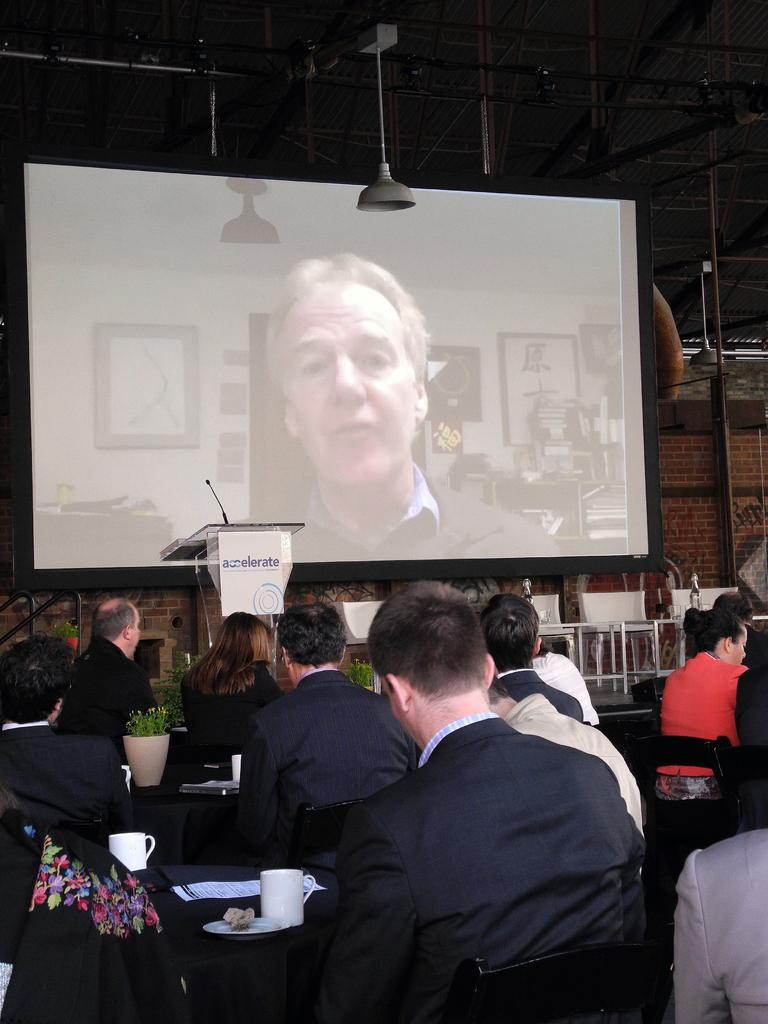What is the main activity taking place in the image? Many people are sitting on chairs in the image, suggesting a gathering or event. What can be found on the stage in the image? There are chairs and a projector screen on the stage in the image. What is the purpose of the mic table in the image? The mic table is likely used for holding microphones, which may be used for speeches or presentations. What type of metal is being used to make the eggs in the image? There are no eggs or metal present in the image. Is there a ball visible on the stage in the image? There is no ball visible on the stage or anywhere else in the image. 